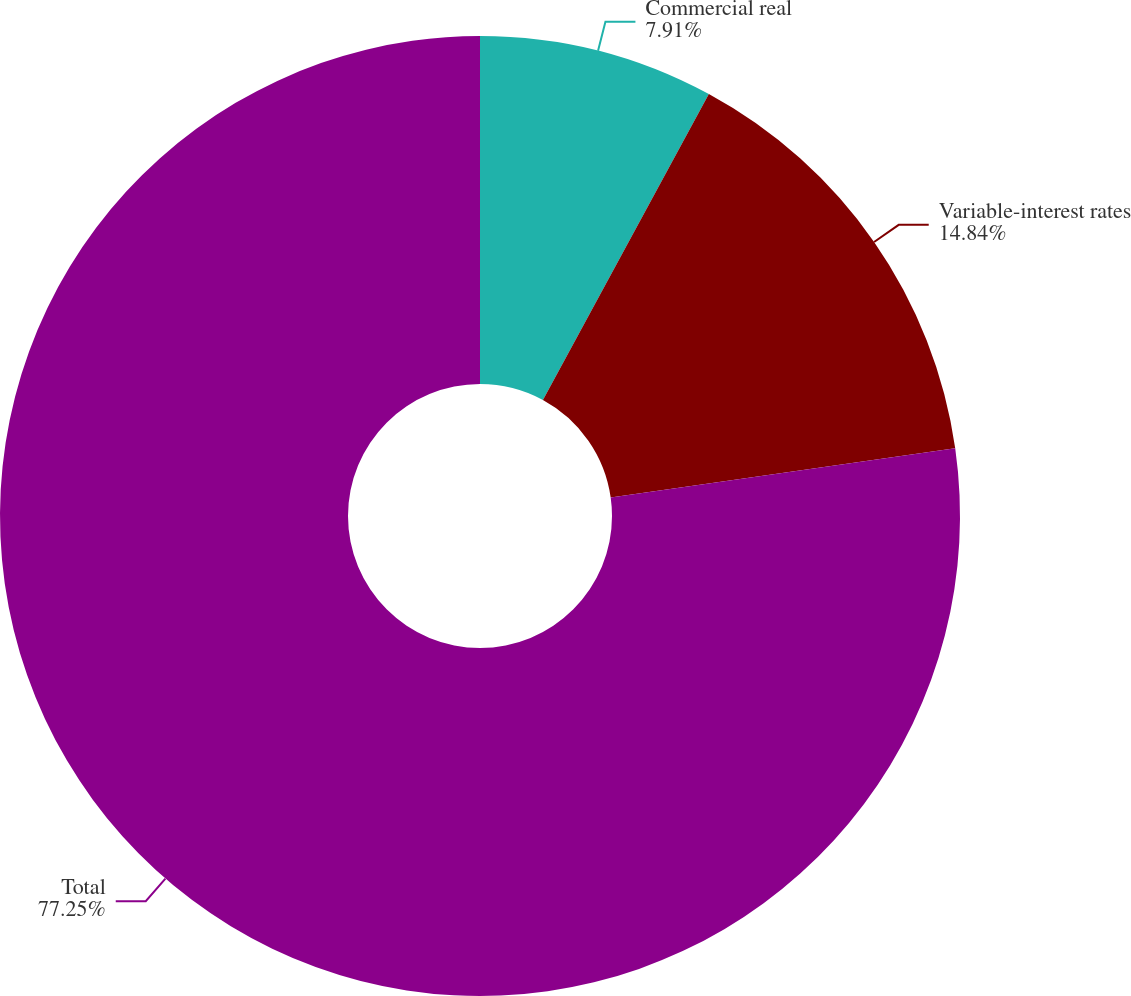Convert chart to OTSL. <chart><loc_0><loc_0><loc_500><loc_500><pie_chart><fcel>Commercial real<fcel>Variable-interest rates<fcel>Total<nl><fcel>7.91%<fcel>14.84%<fcel>77.25%<nl></chart> 